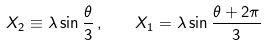<formula> <loc_0><loc_0><loc_500><loc_500>X _ { 2 } \equiv \lambda \sin \frac { \theta } { 3 } \, , \quad X _ { 1 } = \lambda \sin \frac { \theta + 2 \pi } { 3 }</formula> 